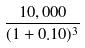<formula> <loc_0><loc_0><loc_500><loc_500>\frac { 1 0 , 0 0 0 } { ( 1 + 0 . 1 0 ) ^ { 3 } }</formula> 